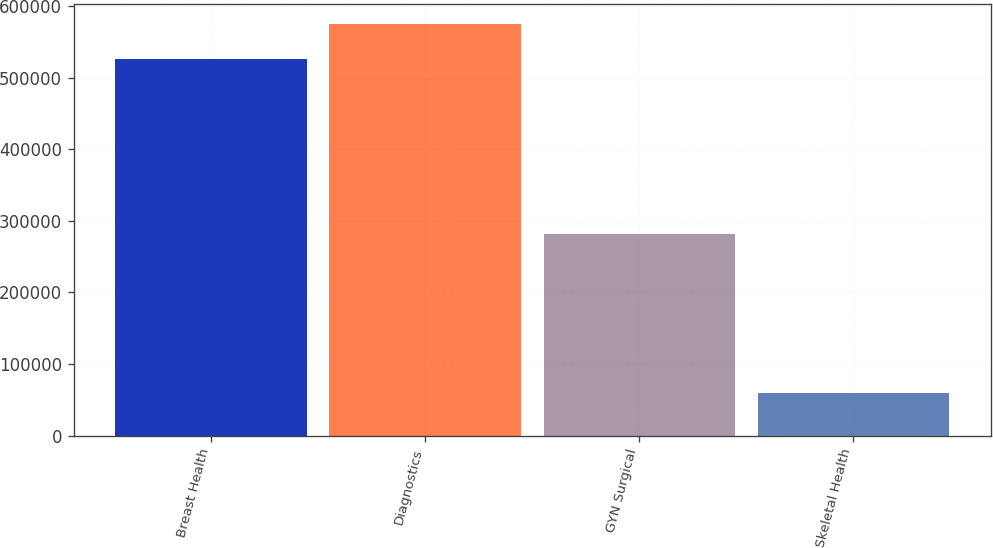Convert chart. <chart><loc_0><loc_0><loc_500><loc_500><bar_chart><fcel>Breast Health<fcel>Diagnostics<fcel>GYN Surgical<fcel>Skeletal Health<nl><fcel>525622<fcel>574597<fcel>281364<fcel>59082<nl></chart> 